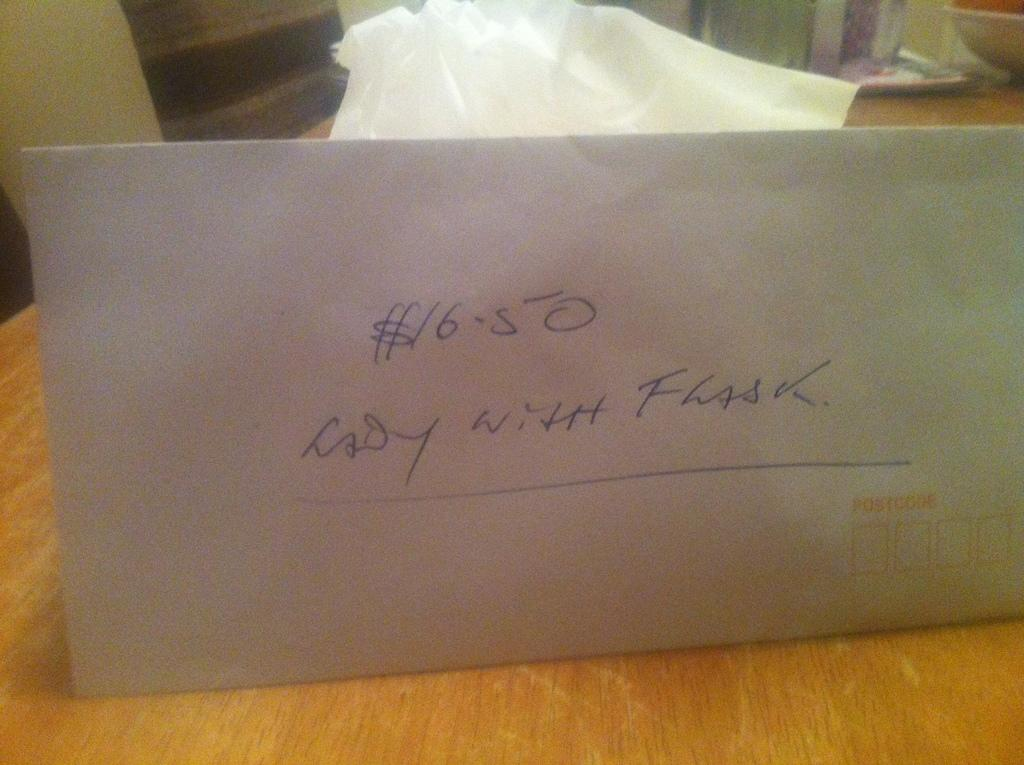Provide a one-sentence caption for the provided image. An envelope containing $16.50 sits propped up on a wooden table. 